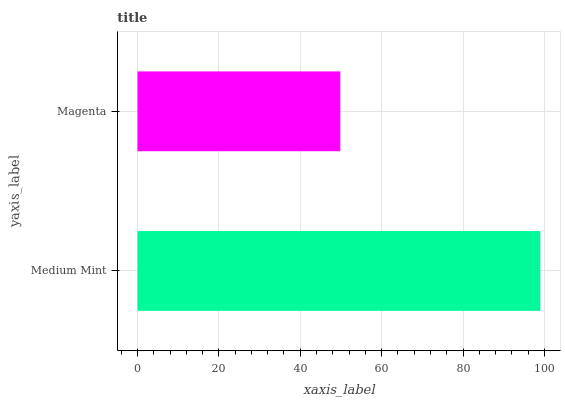Is Magenta the minimum?
Answer yes or no. Yes. Is Medium Mint the maximum?
Answer yes or no. Yes. Is Magenta the maximum?
Answer yes or no. No. Is Medium Mint greater than Magenta?
Answer yes or no. Yes. Is Magenta less than Medium Mint?
Answer yes or no. Yes. Is Magenta greater than Medium Mint?
Answer yes or no. No. Is Medium Mint less than Magenta?
Answer yes or no. No. Is Medium Mint the high median?
Answer yes or no. Yes. Is Magenta the low median?
Answer yes or no. Yes. Is Magenta the high median?
Answer yes or no. No. Is Medium Mint the low median?
Answer yes or no. No. 